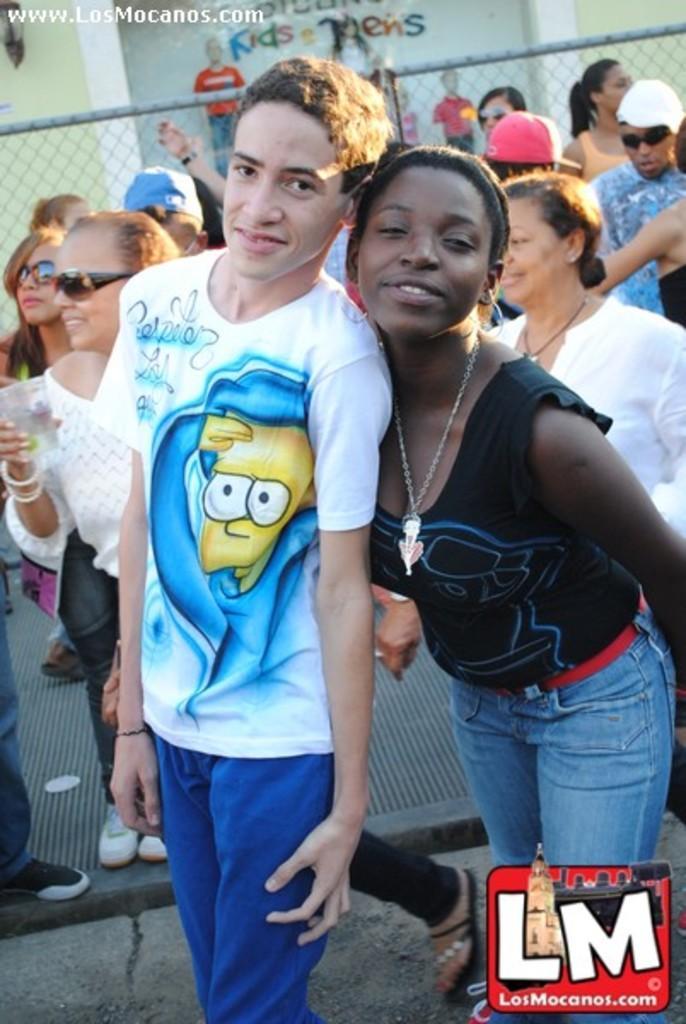Can you describe this image briefly? In this image there are a few people standing and walking, behind them there is a metal rod fence, on the other side of the fence there is a wall with some mannequins. 